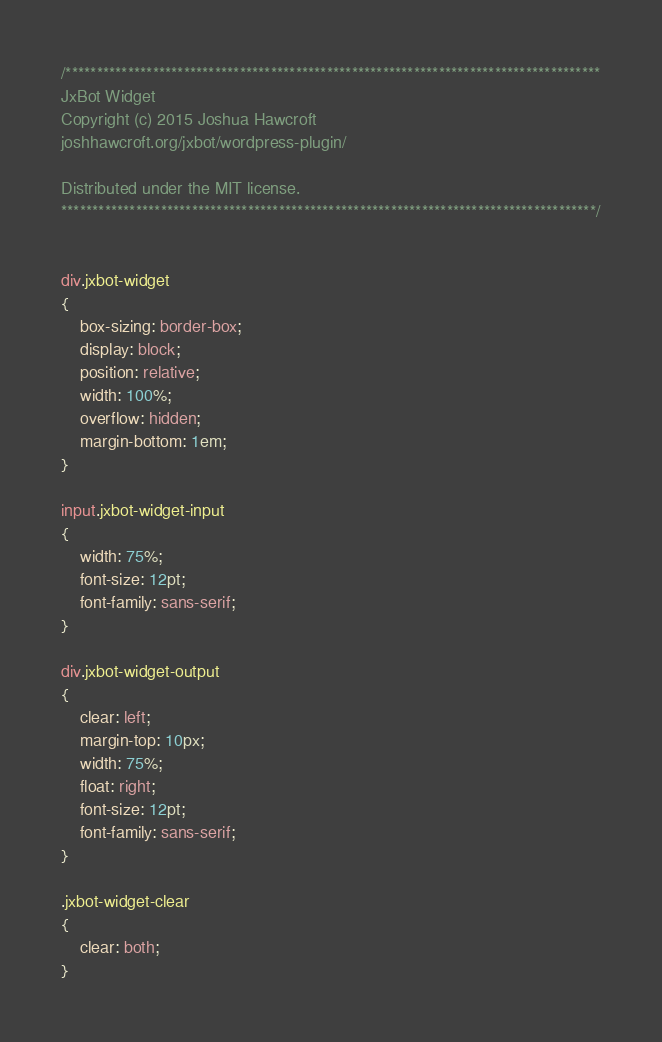<code> <loc_0><loc_0><loc_500><loc_500><_CSS_>/**************************************************************************************
JxBot Widget
Copyright (c) 2015 Joshua Hawcroft
joshhawcroft.org/jxbot/wordpress-plugin/

Distributed under the MIT license.
**************************************************************************************/


div.jxbot-widget
{
	box-sizing: border-box;
	display: block;
	position: relative;
	width: 100%;
	overflow: hidden;
	margin-bottom: 1em;
}

input.jxbot-widget-input
{
	width: 75%;
	font-size: 12pt;
	font-family: sans-serif;
}

div.jxbot-widget-output
{
	clear: left;
	margin-top: 10px;
	width: 75%;
	float: right;
	font-size: 12pt;
	font-family: sans-serif;
}

.jxbot-widget-clear
{
	clear: both;
}

</code> 